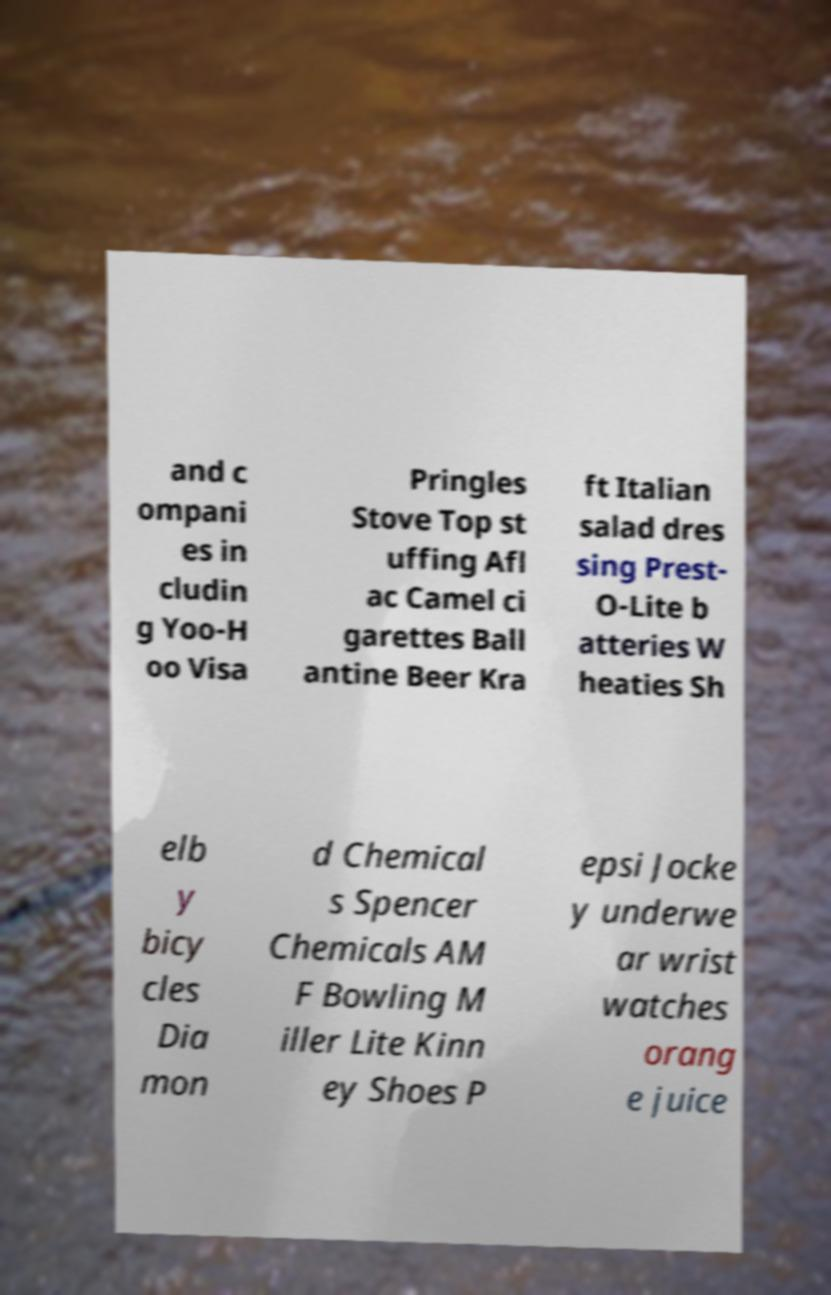Please read and relay the text visible in this image. What does it say? and c ompani es in cludin g Yoo-H oo Visa Pringles Stove Top st uffing Afl ac Camel ci garettes Ball antine Beer Kra ft Italian salad dres sing Prest- O-Lite b atteries W heaties Sh elb y bicy cles Dia mon d Chemical s Spencer Chemicals AM F Bowling M iller Lite Kinn ey Shoes P epsi Jocke y underwe ar wrist watches orang e juice 